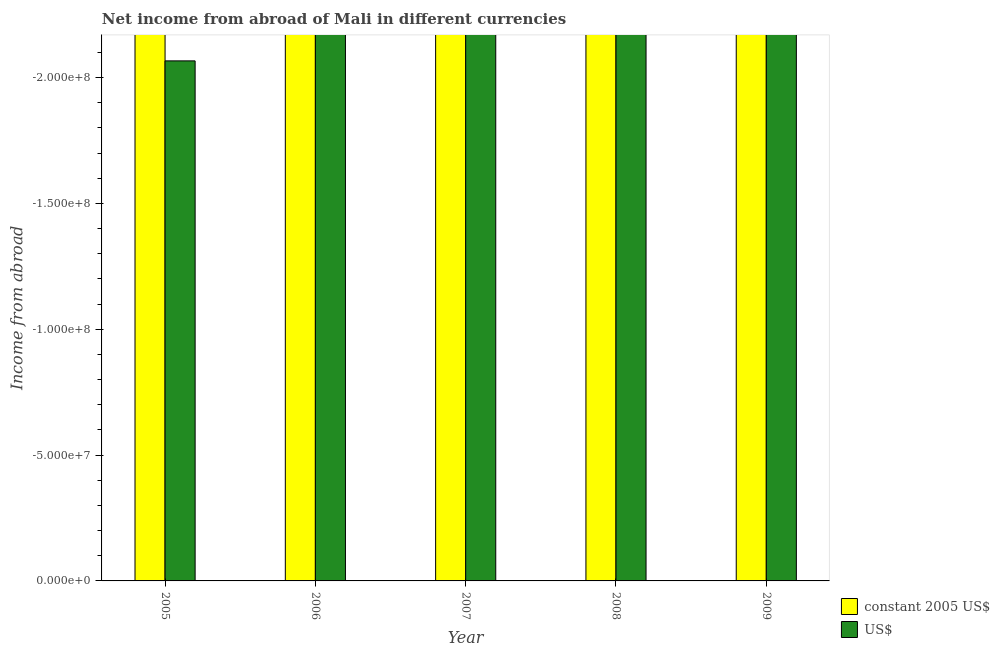How many different coloured bars are there?
Offer a very short reply. 0. How many bars are there on the 1st tick from the left?
Provide a short and direct response. 0. What is the difference between the income from abroad in us$ in 2008 and the income from abroad in constant 2005 us$ in 2006?
Provide a short and direct response. 0. In how many years, is the income from abroad in us$ greater than -50000000 units?
Offer a very short reply. 0. Are all the bars in the graph horizontal?
Your answer should be very brief. No. Are the values on the major ticks of Y-axis written in scientific E-notation?
Offer a terse response. Yes. Does the graph contain any zero values?
Your answer should be very brief. Yes. Does the graph contain grids?
Your answer should be very brief. No. Where does the legend appear in the graph?
Give a very brief answer. Bottom right. How are the legend labels stacked?
Make the answer very short. Vertical. What is the title of the graph?
Offer a very short reply. Net income from abroad of Mali in different currencies. Does "Excluding technical cooperation" appear as one of the legend labels in the graph?
Your answer should be compact. No. What is the label or title of the X-axis?
Your response must be concise. Year. What is the label or title of the Y-axis?
Provide a short and direct response. Income from abroad. What is the Income from abroad in constant 2005 US$ in 2005?
Your answer should be very brief. 0. What is the Income from abroad of US$ in 2006?
Provide a succinct answer. 0. What is the Income from abroad in constant 2005 US$ in 2007?
Make the answer very short. 0. What is the Income from abroad in constant 2005 US$ in 2008?
Provide a succinct answer. 0. What is the Income from abroad in US$ in 2008?
Your answer should be very brief. 0. What is the total Income from abroad in US$ in the graph?
Provide a short and direct response. 0. What is the average Income from abroad of constant 2005 US$ per year?
Make the answer very short. 0. What is the average Income from abroad of US$ per year?
Your response must be concise. 0. 